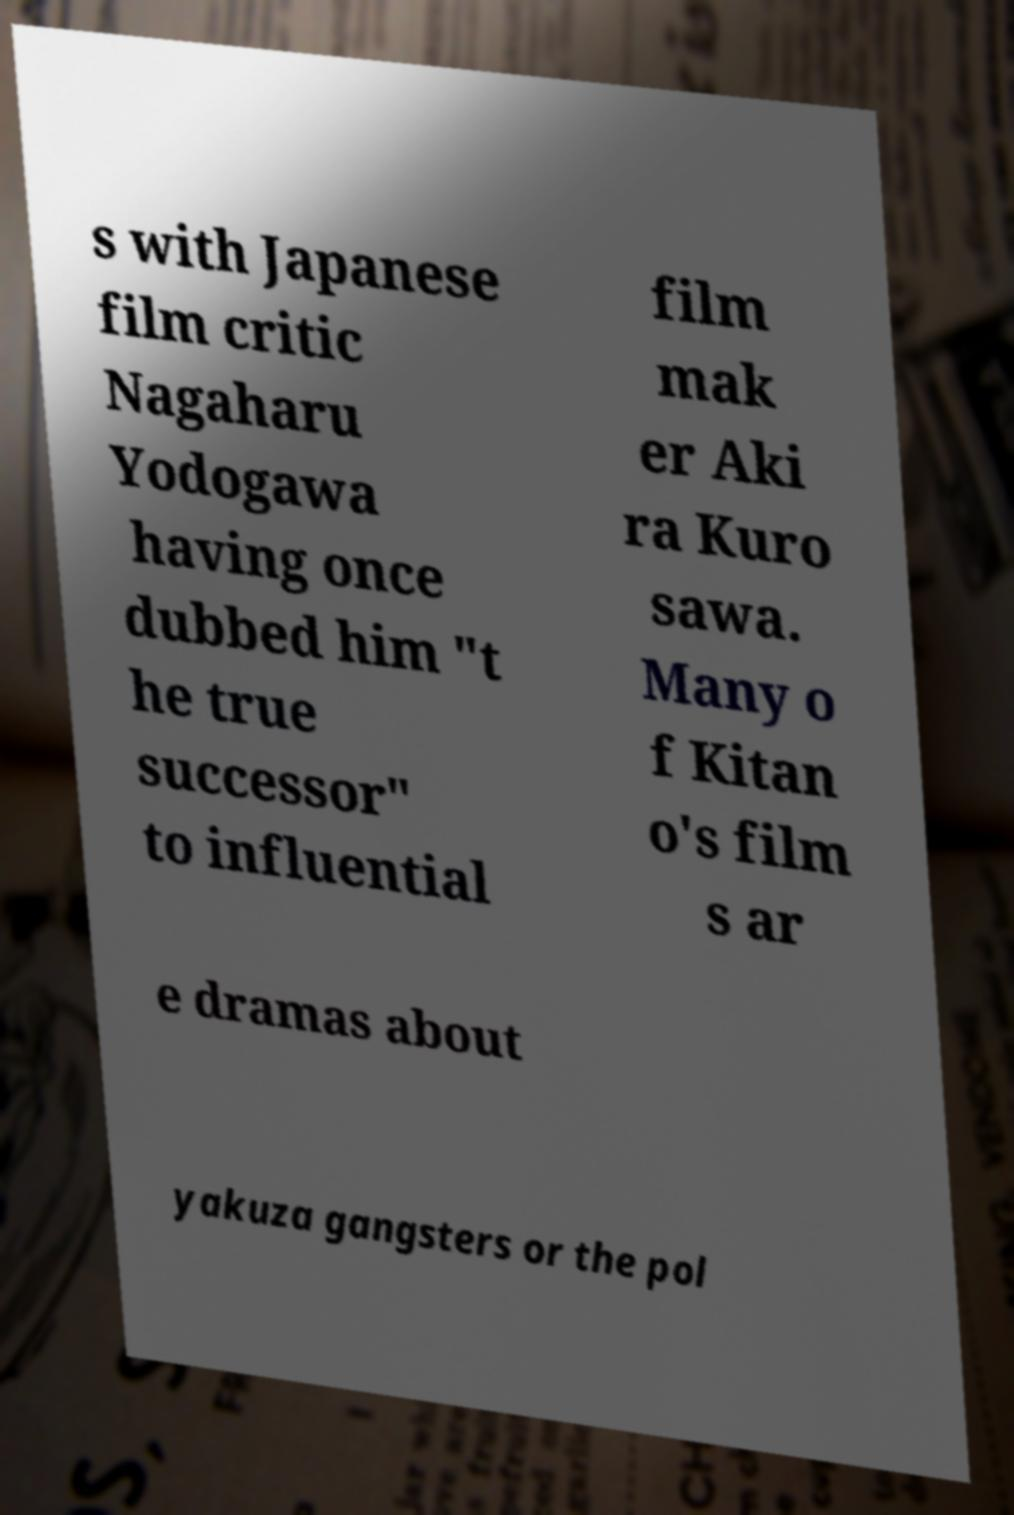I need the written content from this picture converted into text. Can you do that? s with Japanese film critic Nagaharu Yodogawa having once dubbed him "t he true successor" to influential film mak er Aki ra Kuro sawa. Many o f Kitan o's film s ar e dramas about yakuza gangsters or the pol 